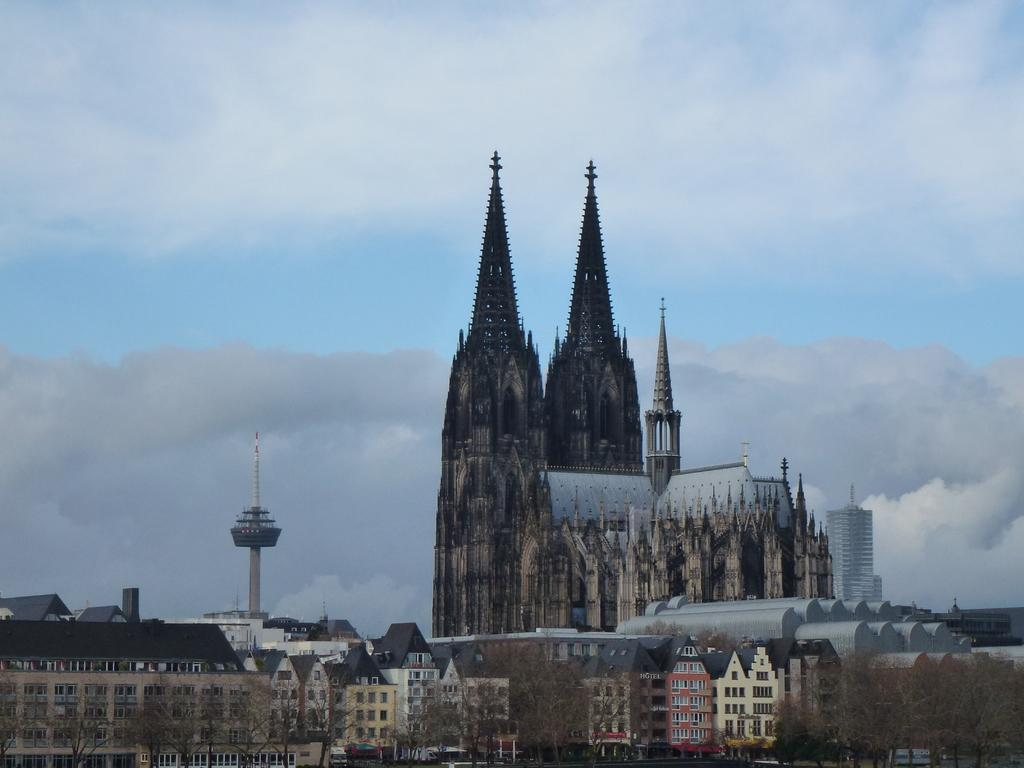What type of structures can be seen in the image? There are buildings in the image. What else is present in the image besides the buildings? There are pipes and trees visible in the image. How are the trees positioned in relation to the buildings? The trees are visible in front of the buildings. What can be seen in the background of the image? The sky is visible in the background of the image. What is the weather like in the image? The sky appears to be cloudy in the image. How does the family react to the shocking event in the image? There is no family or shocking event present in the image; it features buildings, pipes, trees, and a cloudy sky. 